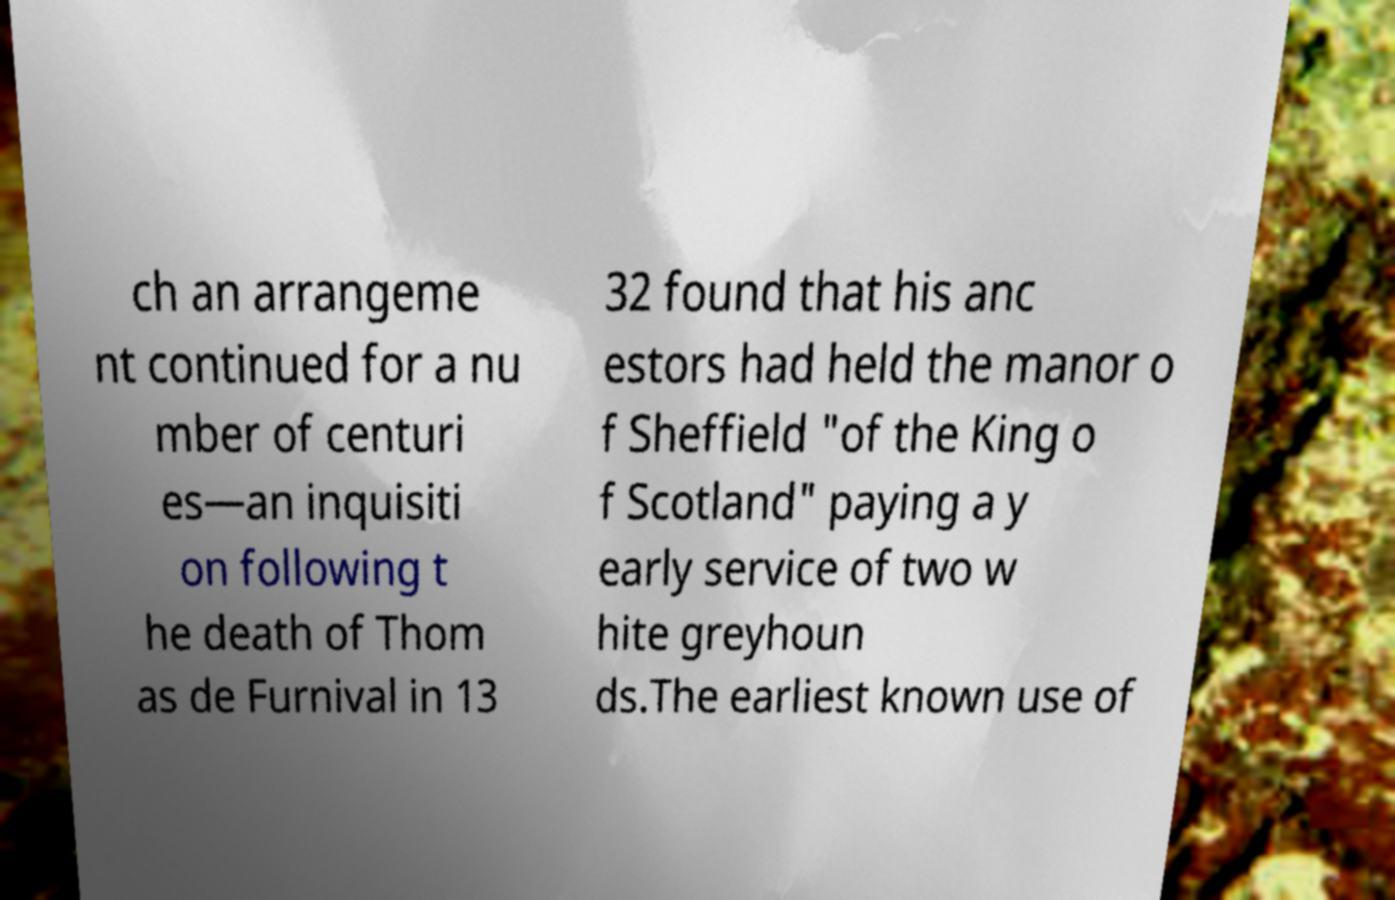I need the written content from this picture converted into text. Can you do that? ch an arrangeme nt continued for a nu mber of centuri es—an inquisiti on following t he death of Thom as de Furnival in 13 32 found that his anc estors had held the manor o f Sheffield "of the King o f Scotland" paying a y early service of two w hite greyhoun ds.The earliest known use of 